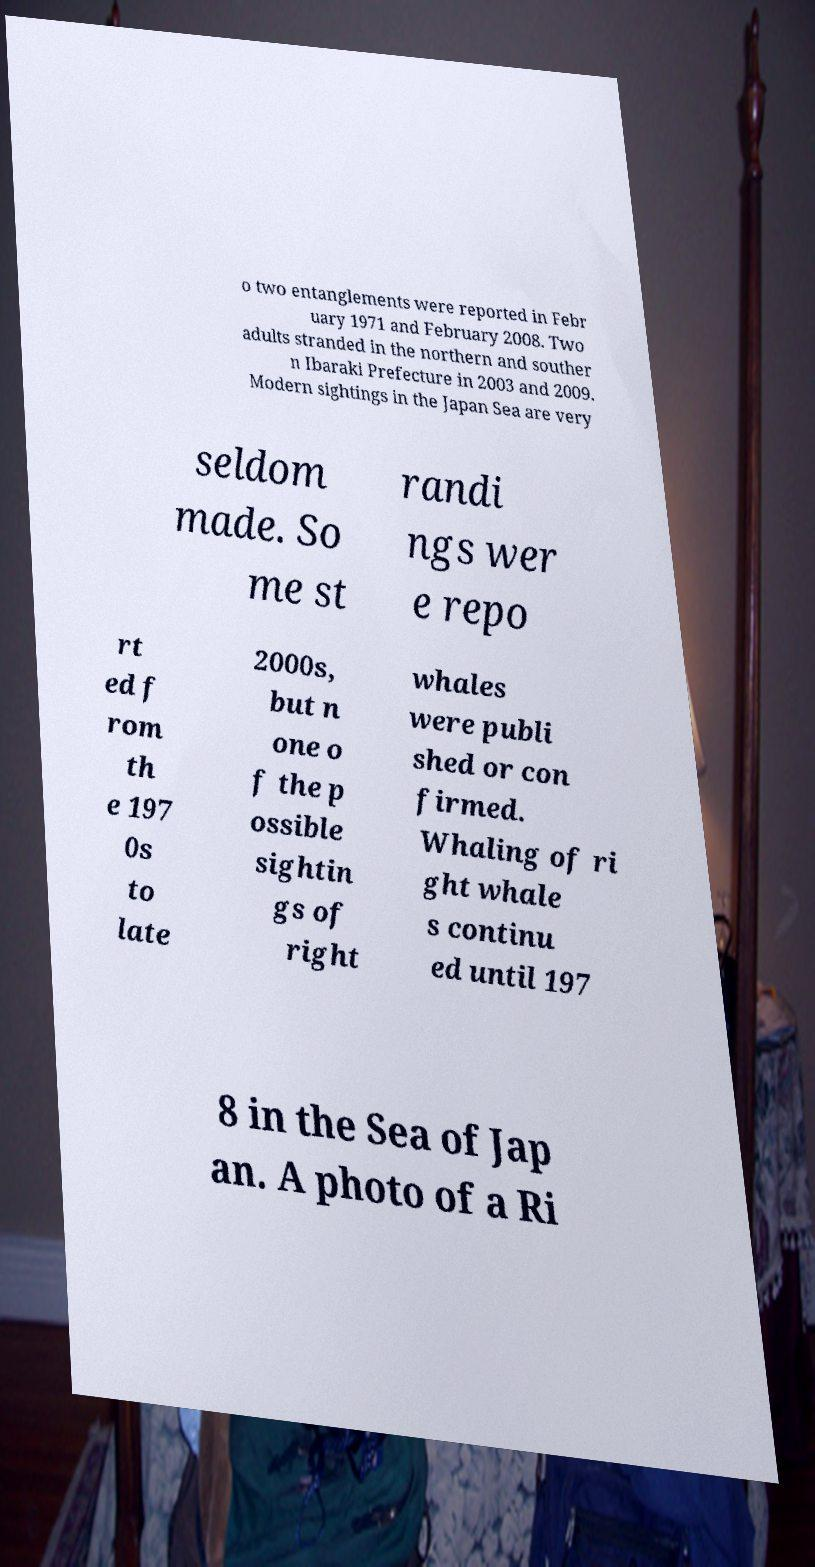Could you extract and type out the text from this image? o two entanglements were reported in Febr uary 1971 and February 2008. Two adults stranded in the northern and souther n Ibaraki Prefecture in 2003 and 2009. Modern sightings in the Japan Sea are very seldom made. So me st randi ngs wer e repo rt ed f rom th e 197 0s to late 2000s, but n one o f the p ossible sightin gs of right whales were publi shed or con firmed. Whaling of ri ght whale s continu ed until 197 8 in the Sea of Jap an. A photo of a Ri 